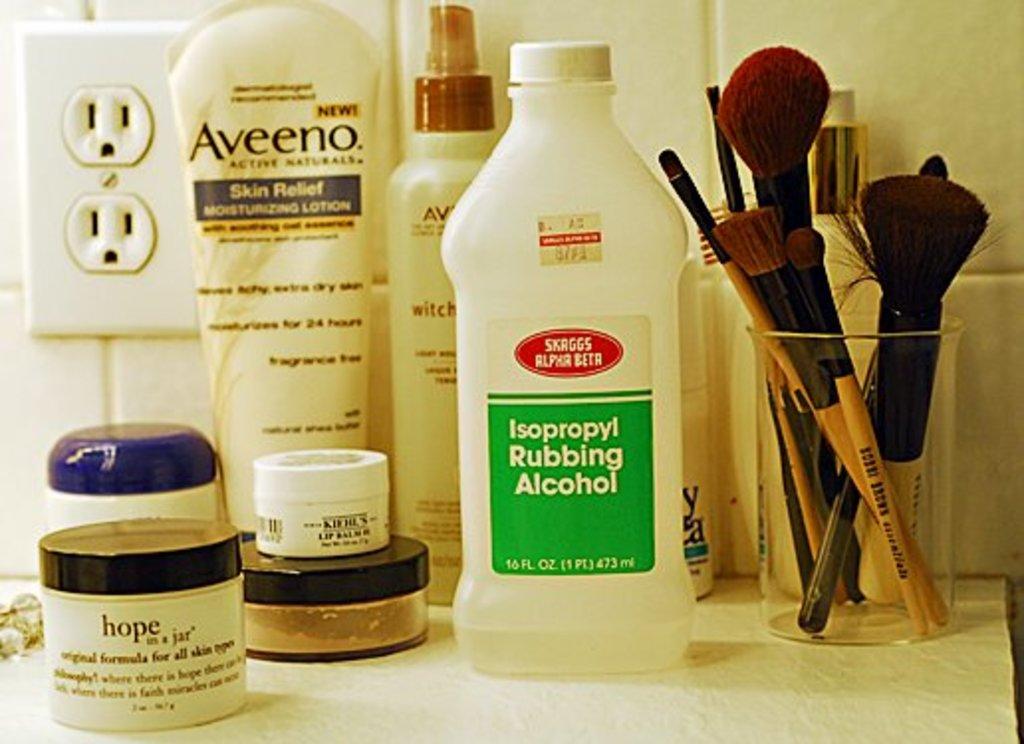What brand of lotion is next to the electrical outlet?
Ensure brevity in your answer.  Aveeno. What is in the containers>?
Provide a succinct answer. Isopropyl rubbing alcohol. 